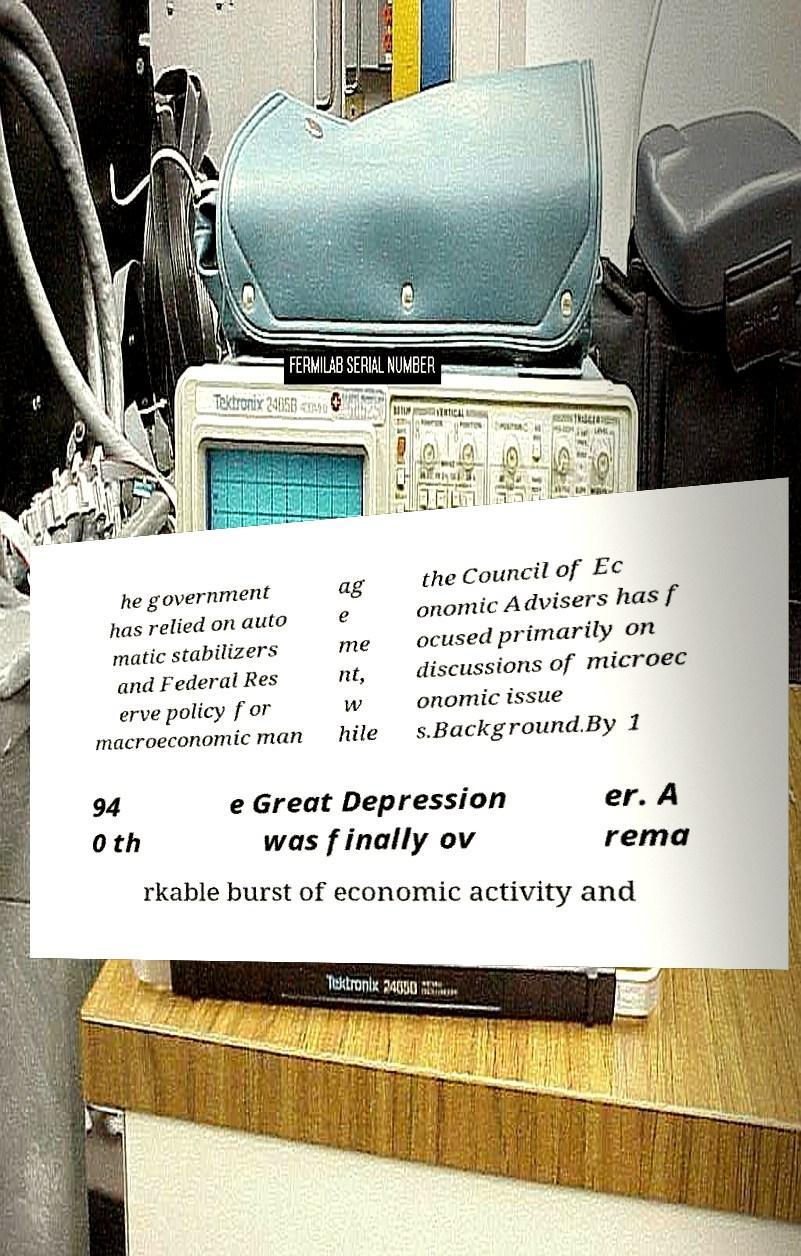There's text embedded in this image that I need extracted. Can you transcribe it verbatim? he government has relied on auto matic stabilizers and Federal Res erve policy for macroeconomic man ag e me nt, w hile the Council of Ec onomic Advisers has f ocused primarily on discussions of microec onomic issue s.Background.By 1 94 0 th e Great Depression was finally ov er. A rema rkable burst of economic activity and 